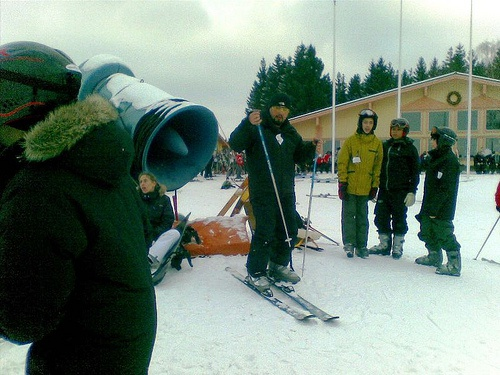Describe the objects in this image and their specific colors. I can see people in ivory, black, darkgreen, and teal tones, people in ivory, black, gray, teal, and darkgray tones, people in ivory, black, teal, and darkgreen tones, people in ivory, olive, black, darkgreen, and teal tones, and people in lightgray, black, teal, navy, and olive tones in this image. 